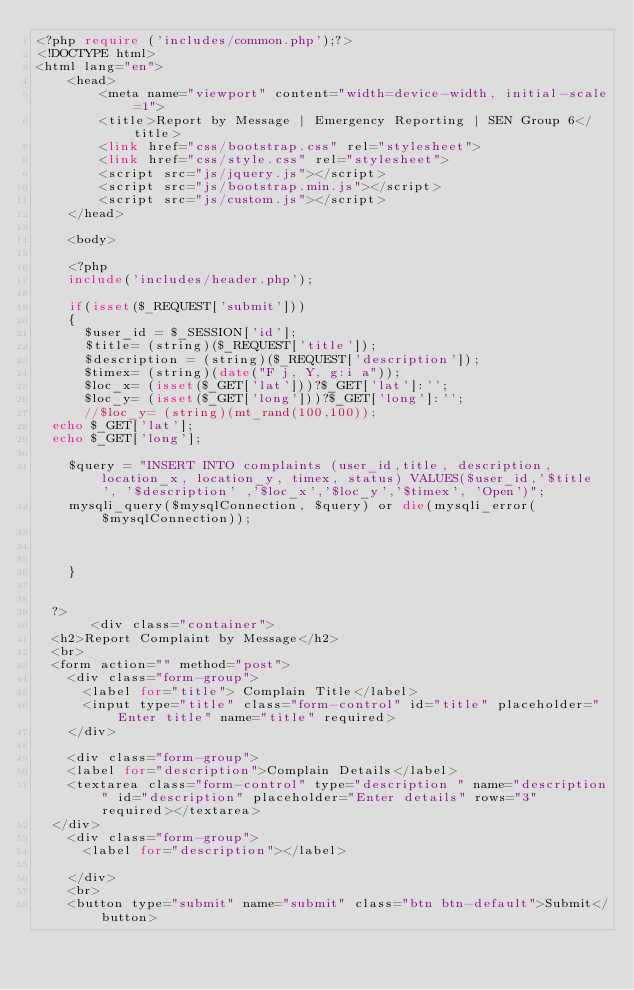Convert code to text. <code><loc_0><loc_0><loc_500><loc_500><_PHP_><?php require ('includes/common.php');?>
<!DOCTYPE html>
<html lang="en">
    <head>
        <meta name="viewport" content="width=device-width, initial-scale=1">
        <title>Report by Message | Emergency Reporting | SEN Group 6</title>
        <link href="css/bootstrap.css" rel="stylesheet">
        <link href="css/style.css" rel="stylesheet">
        <script src="js/jquery.js"></script>
        <script src="js/bootstrap.min.js"></script>
        <script src="js/custom.js"></script>
    </head>
	
    <body>
   
    <?php 
    include('includes/header.php');

    if(isset($_REQUEST['submit']))
    {
      $user_id = $_SESSION['id'];
      $title= (string)($_REQUEST['title']);
      $description = (string)($_REQUEST['description']);
      $timex= (string)(date("F j, Y, g:i a"));
      $loc_x= (isset($_GET['lat']))?$_GET['lat']:'';
      $loc_y= (isset($_GET['long']))?$_GET['long']:'';
      //$loc_y= (string)(mt_rand(100,100)); 
  echo $_GET['lat'];
  echo $_GET['long'];
  
    $query = "INSERT INTO complaints (user_id,title, description, location_x, location_y, timex, status) VALUES($user_id,'$title', '$description' ,'$loc_x','$loc_y','$timex', 'Open')";
    mysqli_query($mysqlConnection, $query) or die(mysqli_error($mysqlConnection));
    


    }


  ?>
       <div class="container">
  <h2>Report Complaint by Message</h2>
  <br>
  <form action="" method="post">
    <div class="form-group">
      <label for="title"> Complain Title</label>
      <input type="title" class="form-control" id="title" placeholder="Enter title" name="title" required>
    </div>
    
    <div class="form-group">
    <label for="description">Complain Details</label>
    <textarea class="form-control" type="description " name="description" id="description" placeholder="Enter details" rows="3" required></textarea>
  </div>
    <div class="form-group">
      <label for="description"></label>
      
    </div>
    <br>
    <button type="submit" name="submit" class="btn btn-default">Submit</button></code> 